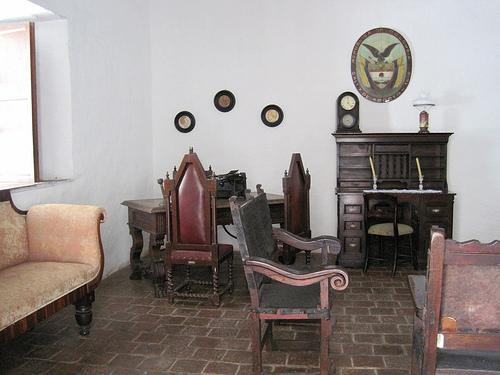Question: what room is this?
Choices:
A. A kitchen.
B. A sitting area.
C. A bedroom.
D. A basement.
Answer with the letter. Answer: B Question: what is the floor made of?
Choices:
A. Wood.
B. Cement.
C. Brick.
D. Stone.
Answer with the letter. Answer: C Question: how many round pictures are on the wall?
Choices:
A. Two.
B. Three.
C. None.
D. Five.
Answer with the letter. Answer: B Question: where is the clock?
Choices:
A. On the wall.
B. On the desk.
C. On the taller desk.
D. On the dresser.
Answer with the letter. Answer: C Question: what else is on the taller desk?
Choices:
A. A pile of paper.
B. A few pens.
C. A computer.
D. A lamp.
Answer with the letter. Answer: D 